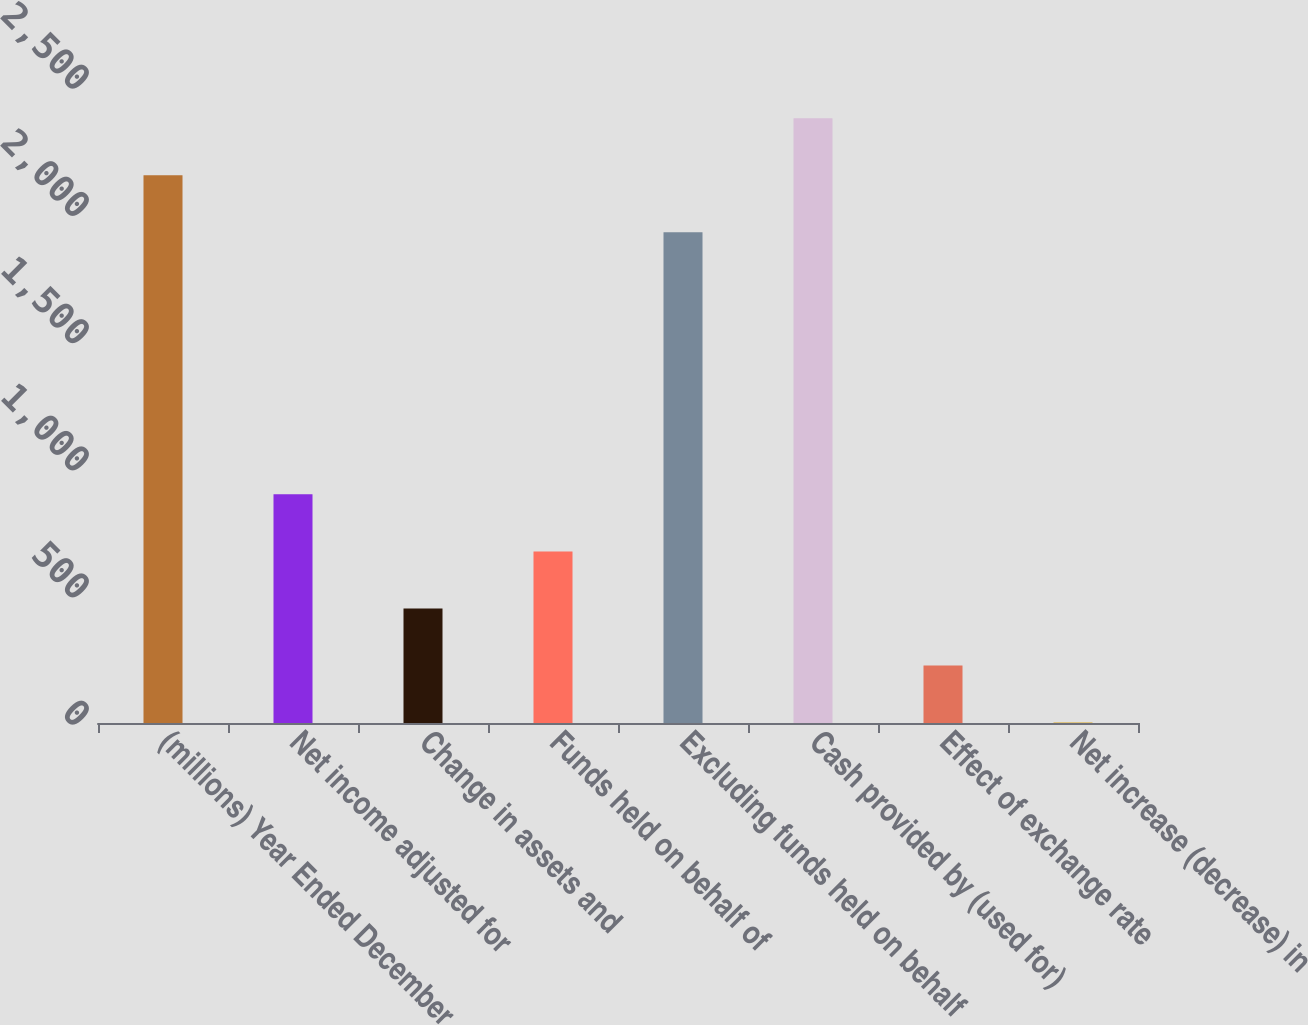Convert chart. <chart><loc_0><loc_0><loc_500><loc_500><bar_chart><fcel>(millions) Year Ended December<fcel>Net income adjusted for<fcel>Change in assets and<fcel>Funds held on behalf of<fcel>Excluding funds held on behalf<fcel>Cash provided by (used for)<fcel>Effect of exchange rate<fcel>Net increase (decrease) in<nl><fcel>2153.2<fcel>898.8<fcel>450.4<fcel>674.6<fcel>1929<fcel>2377.4<fcel>226.2<fcel>2<nl></chart> 